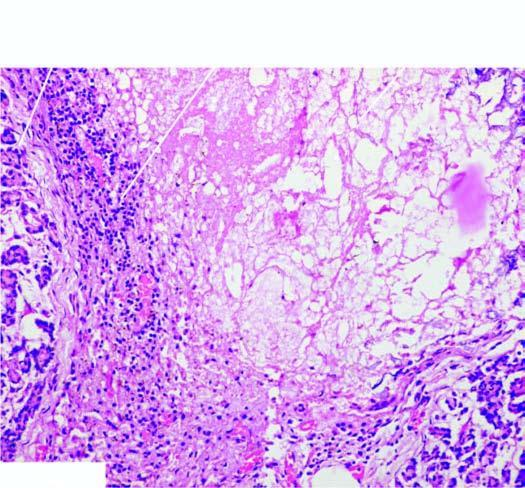what is surrounded by mixed inflammatory infiltrate with granulation tissue formation?
Answer the question using a single word or phrase. Necrotic tissue 